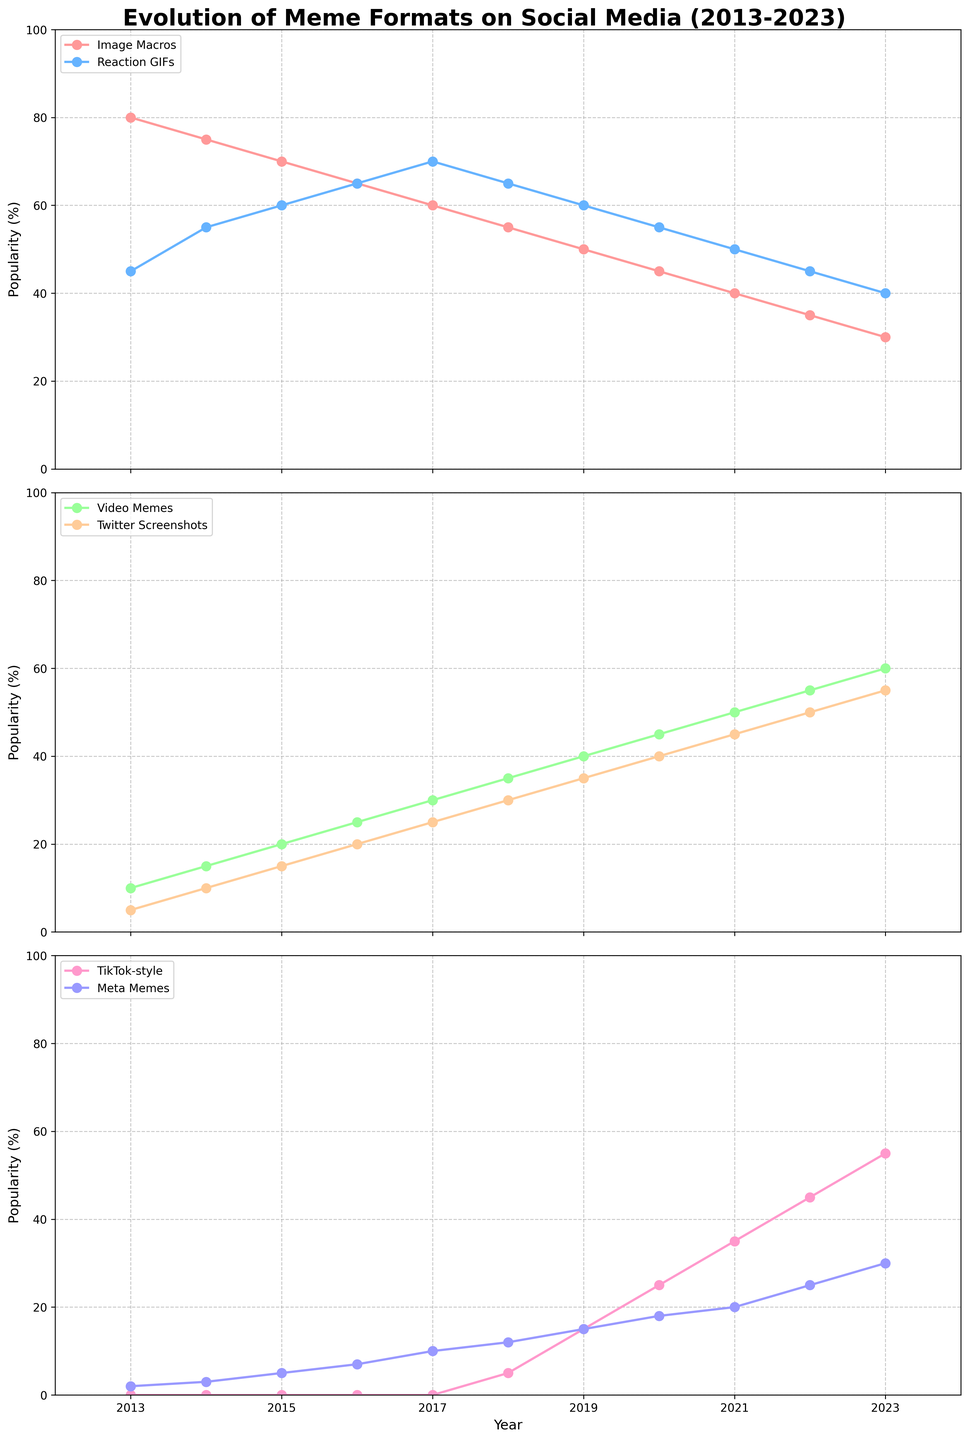What's the general trend of Image Macros from 2013 to 2023? From the plot, we can see that the popularity of Image Macros consistently decreases over the years. Starting at 80% in 2013 and dropping steadily to 30% by 2023.
Answer: Decreasing When did TikTok-style memes first appear and how did their popularity change by 2023? TikTok-style memes first appeared in 2018 with a popularity of 5%. By 2023, their popularity increased to 55%. This is a significant increase in popularity over five years.
Answer: First appeared in 2018, increased to 55% by 2023 Which meme format had the highest popularity in 2023? In 2023, TikTok-style memes had the highest popularity at 55%, which is higher than any other meme format in that year.
Answer: TikTok-style memes How did the popularity of Twitter Screenshots change from 2015 to 2023? In 2015, Twitter Screenshot memes had a popularity of 15%, which increased steadily to 55% by 2023. This indicates a consistently rising trend.
Answer: Increased from 15% to 55% Compare the popularity trends of Video Memes and Meta Memes from 2013 to 2023. Video Memes started at 10% in 2013 and increased to 60% by 2023. Meta Memes started at 2% and increased to 30% over the same period. Both trends show an increase, but Video Memes saw a larger and more consistent rise than Meta Memes.
Answer: Both increased, Video Memes saw a larger rise Which meme format was the least popular in 2013 and how has it evolved since then? Meta Memes were the least popular in 2013 with a popularity of 2%. Over the years, their popularity has gradually increased to 30% by 2023.
Answer: Meta Memes, increased to 30% What is the average popularity of Reaction GIFs from 2013 to 2023? Summing the popularity values of Reaction GIFs from 2013 to 2023 (45 + 55 + 60 + 65 + 70 + 65 + 60 + 55 + 50 + 45 + 40) equals 610. Dividing by 11 years gives an average popularity of 55.5%.
Answer: 55.5% Describe the trend of popularity for Image Macros and Reaction GIFs and identify the point when Reaction GIFs surpassed Image Macros. Image Macros trend downwards and Reaction GIFs trend upwards in the earlier years. Reaction GIFs surpassed Image Macros in 2016 when Reaction GIFs were at 65% and Image Macros at 65%.
Answer: Reaction GIFs surpassed Image Macros in 2016 Which meme formats first showed a popularity percentage in 2013? In 2013, the meme formats that had a visible popularity percentage were Image Macros (80%), Reaction GIFs (45%), Video Memes (10%), Twitter Screenshots (5%), and Meta Memes (2%).
Answer: Image Macros, Reaction GIFs, Video Memes, Twitter Screenshots, Meta Memes 